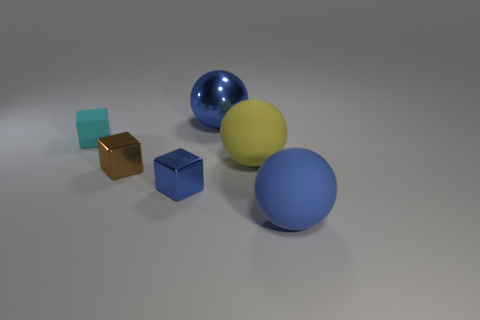What color is the matte sphere that is to the right of the large yellow sphere? The matte sphere to the right of the large yellow sphere has a bold blue color. It distinguishes itself by having a soft, non-reflective surface in contrast to its glossy counterparts. 